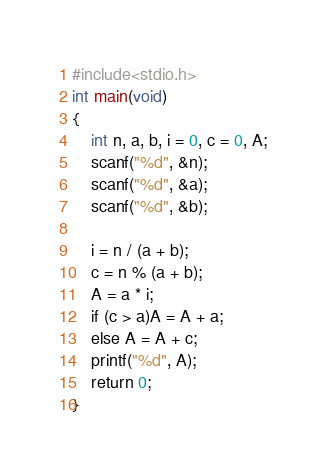Convert code to text. <code><loc_0><loc_0><loc_500><loc_500><_C_>#include<stdio.h>
int main(void)
{
	int n, a, b, i = 0, c = 0, A;
	scanf("%d", &n);
	scanf("%d", &a);
	scanf("%d", &b);

	i = n / (a + b);
	c = n % (a + b);
	A = a * i;
	if (c > a)A = A + a;
	else A = A + c;
	printf("%d", A);
	return 0;
}
</code> 